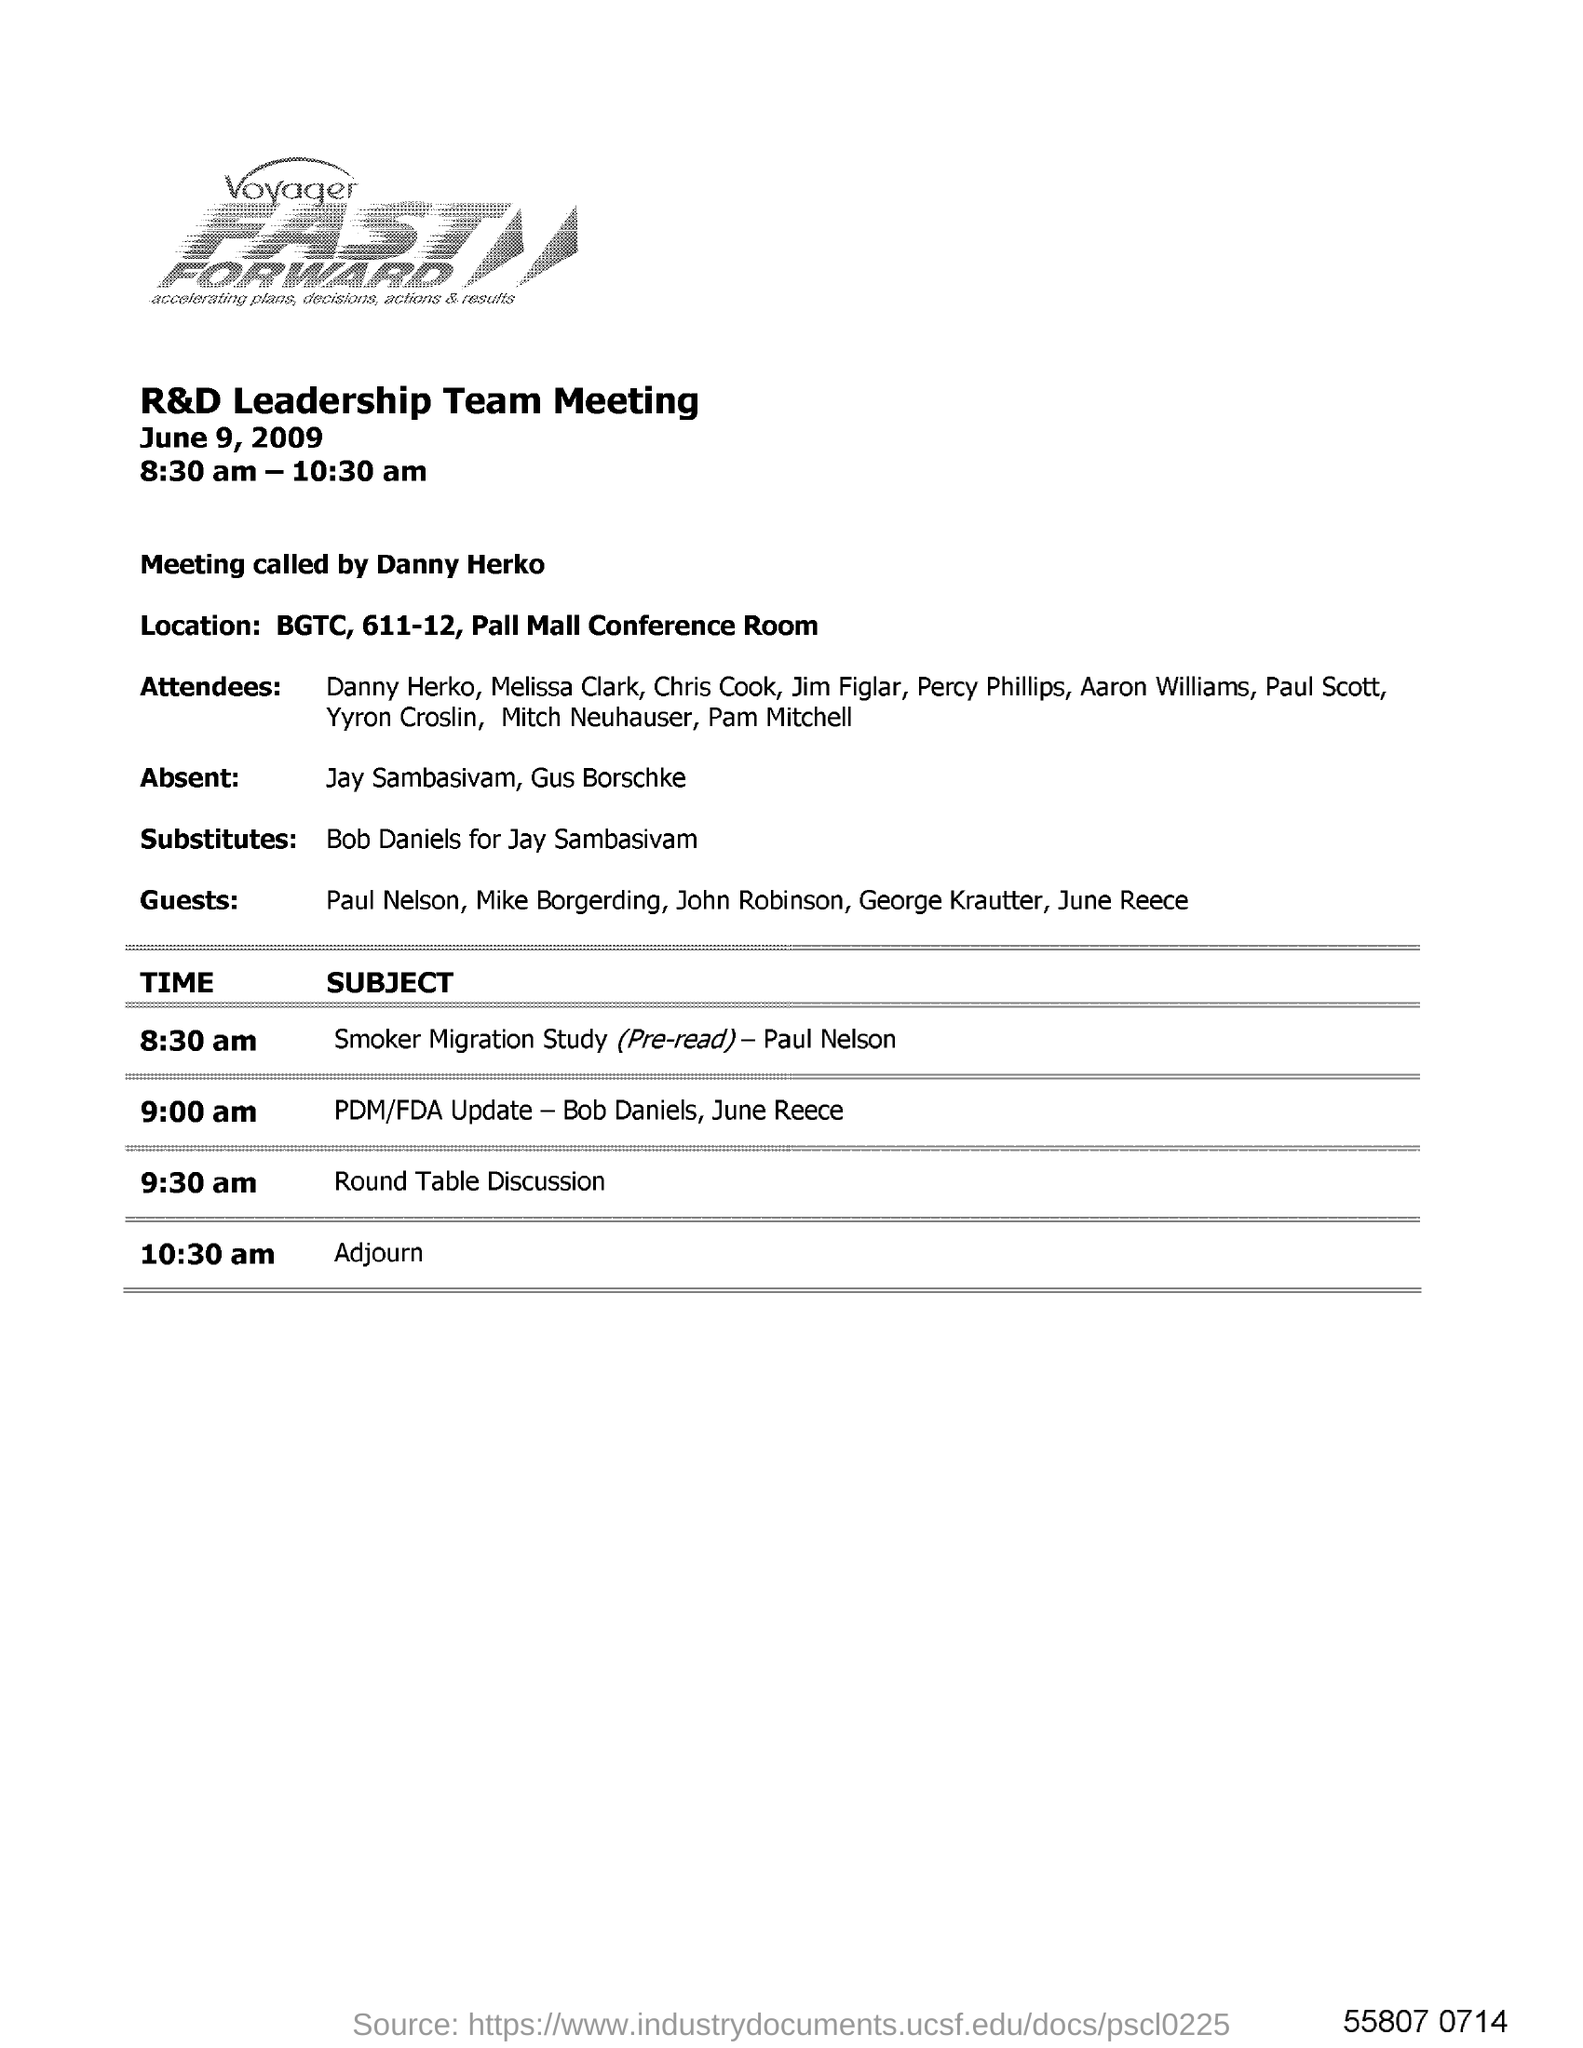Give some essential details in this illustration. The R&D Leadership team meeting took place from 8:30 am to 10:30 am. FASTForward is a powerful tool that enables users to quickly and efficiently accelerate their plans, decisions, actions, and results. The round table discussion began at 9:30 a.m. The person who called the meeting is Danny Herko. Those who were absent from the meeting were Jay Sambasivam and Gus Borschke. 